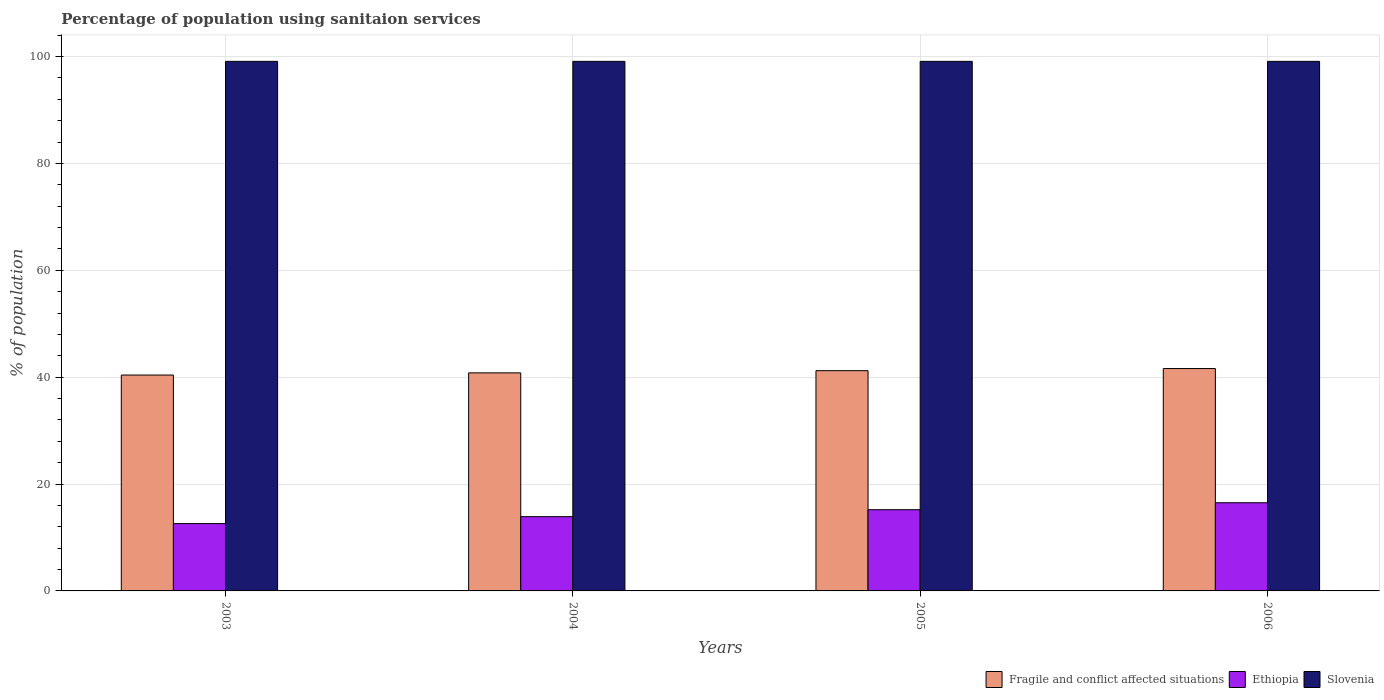Are the number of bars per tick equal to the number of legend labels?
Your answer should be very brief. Yes. How many bars are there on the 2nd tick from the left?
Provide a succinct answer. 3. In how many cases, is the number of bars for a given year not equal to the number of legend labels?
Your response must be concise. 0. What is the percentage of population using sanitaion services in Slovenia in 2005?
Give a very brief answer. 99.1. Across all years, what is the minimum percentage of population using sanitaion services in Ethiopia?
Provide a short and direct response. 12.6. In which year was the percentage of population using sanitaion services in Ethiopia minimum?
Your answer should be compact. 2003. What is the total percentage of population using sanitaion services in Ethiopia in the graph?
Provide a short and direct response. 58.2. What is the difference between the percentage of population using sanitaion services in Fragile and conflict affected situations in 2003 and that in 2004?
Keep it short and to the point. -0.41. What is the difference between the percentage of population using sanitaion services in Slovenia in 2006 and the percentage of population using sanitaion services in Ethiopia in 2004?
Provide a short and direct response. 85.2. What is the average percentage of population using sanitaion services in Ethiopia per year?
Your response must be concise. 14.55. In the year 2005, what is the difference between the percentage of population using sanitaion services in Ethiopia and percentage of population using sanitaion services in Fragile and conflict affected situations?
Your response must be concise. -26.02. In how many years, is the percentage of population using sanitaion services in Slovenia greater than 16 %?
Ensure brevity in your answer.  4. What is the ratio of the percentage of population using sanitaion services in Fragile and conflict affected situations in 2003 to that in 2004?
Keep it short and to the point. 0.99. Is the percentage of population using sanitaion services in Fragile and conflict affected situations in 2005 less than that in 2006?
Give a very brief answer. Yes. Is the difference between the percentage of population using sanitaion services in Ethiopia in 2005 and 2006 greater than the difference between the percentage of population using sanitaion services in Fragile and conflict affected situations in 2005 and 2006?
Provide a succinct answer. No. What is the difference between the highest and the second highest percentage of population using sanitaion services in Ethiopia?
Your answer should be very brief. 1.3. What is the difference between the highest and the lowest percentage of population using sanitaion services in Ethiopia?
Ensure brevity in your answer.  3.9. Is the sum of the percentage of population using sanitaion services in Ethiopia in 2003 and 2004 greater than the maximum percentage of population using sanitaion services in Fragile and conflict affected situations across all years?
Your response must be concise. No. What does the 3rd bar from the left in 2006 represents?
Provide a short and direct response. Slovenia. What does the 1st bar from the right in 2003 represents?
Make the answer very short. Slovenia. How many bars are there?
Ensure brevity in your answer.  12. Are all the bars in the graph horizontal?
Provide a short and direct response. No. How many years are there in the graph?
Ensure brevity in your answer.  4. What is the difference between two consecutive major ticks on the Y-axis?
Provide a succinct answer. 20. Are the values on the major ticks of Y-axis written in scientific E-notation?
Provide a succinct answer. No. How are the legend labels stacked?
Ensure brevity in your answer.  Horizontal. What is the title of the graph?
Ensure brevity in your answer.  Percentage of population using sanitaion services. What is the label or title of the Y-axis?
Your answer should be very brief. % of population. What is the % of population in Fragile and conflict affected situations in 2003?
Offer a very short reply. 40.4. What is the % of population in Slovenia in 2003?
Provide a succinct answer. 99.1. What is the % of population in Fragile and conflict affected situations in 2004?
Your response must be concise. 40.81. What is the % of population of Ethiopia in 2004?
Provide a succinct answer. 13.9. What is the % of population of Slovenia in 2004?
Ensure brevity in your answer.  99.1. What is the % of population of Fragile and conflict affected situations in 2005?
Provide a succinct answer. 41.22. What is the % of population of Ethiopia in 2005?
Offer a terse response. 15.2. What is the % of population in Slovenia in 2005?
Your answer should be compact. 99.1. What is the % of population of Fragile and conflict affected situations in 2006?
Your answer should be very brief. 41.61. What is the % of population of Slovenia in 2006?
Keep it short and to the point. 99.1. Across all years, what is the maximum % of population of Fragile and conflict affected situations?
Your response must be concise. 41.61. Across all years, what is the maximum % of population in Slovenia?
Ensure brevity in your answer.  99.1. Across all years, what is the minimum % of population of Fragile and conflict affected situations?
Your answer should be compact. 40.4. Across all years, what is the minimum % of population of Ethiopia?
Provide a succinct answer. 12.6. Across all years, what is the minimum % of population in Slovenia?
Provide a short and direct response. 99.1. What is the total % of population in Fragile and conflict affected situations in the graph?
Your response must be concise. 164.04. What is the total % of population of Ethiopia in the graph?
Make the answer very short. 58.2. What is the total % of population in Slovenia in the graph?
Your answer should be compact. 396.4. What is the difference between the % of population of Fragile and conflict affected situations in 2003 and that in 2004?
Offer a very short reply. -0.41. What is the difference between the % of population of Ethiopia in 2003 and that in 2004?
Offer a very short reply. -1.3. What is the difference between the % of population in Fragile and conflict affected situations in 2003 and that in 2005?
Make the answer very short. -0.82. What is the difference between the % of population in Ethiopia in 2003 and that in 2005?
Give a very brief answer. -2.6. What is the difference between the % of population in Fragile and conflict affected situations in 2003 and that in 2006?
Give a very brief answer. -1.22. What is the difference between the % of population in Fragile and conflict affected situations in 2004 and that in 2005?
Make the answer very short. -0.41. What is the difference between the % of population of Ethiopia in 2004 and that in 2005?
Your response must be concise. -1.3. What is the difference between the % of population of Fragile and conflict affected situations in 2004 and that in 2006?
Provide a succinct answer. -0.81. What is the difference between the % of population in Ethiopia in 2004 and that in 2006?
Provide a short and direct response. -2.6. What is the difference between the % of population in Slovenia in 2004 and that in 2006?
Provide a succinct answer. 0. What is the difference between the % of population of Fragile and conflict affected situations in 2005 and that in 2006?
Keep it short and to the point. -0.4. What is the difference between the % of population of Slovenia in 2005 and that in 2006?
Your response must be concise. 0. What is the difference between the % of population in Fragile and conflict affected situations in 2003 and the % of population in Ethiopia in 2004?
Keep it short and to the point. 26.5. What is the difference between the % of population in Fragile and conflict affected situations in 2003 and the % of population in Slovenia in 2004?
Your answer should be compact. -58.7. What is the difference between the % of population in Ethiopia in 2003 and the % of population in Slovenia in 2004?
Ensure brevity in your answer.  -86.5. What is the difference between the % of population of Fragile and conflict affected situations in 2003 and the % of population of Ethiopia in 2005?
Your answer should be very brief. 25.2. What is the difference between the % of population of Fragile and conflict affected situations in 2003 and the % of population of Slovenia in 2005?
Give a very brief answer. -58.7. What is the difference between the % of population of Ethiopia in 2003 and the % of population of Slovenia in 2005?
Your response must be concise. -86.5. What is the difference between the % of population of Fragile and conflict affected situations in 2003 and the % of population of Ethiopia in 2006?
Provide a succinct answer. 23.9. What is the difference between the % of population of Fragile and conflict affected situations in 2003 and the % of population of Slovenia in 2006?
Keep it short and to the point. -58.7. What is the difference between the % of population in Ethiopia in 2003 and the % of population in Slovenia in 2006?
Keep it short and to the point. -86.5. What is the difference between the % of population of Fragile and conflict affected situations in 2004 and the % of population of Ethiopia in 2005?
Offer a terse response. 25.61. What is the difference between the % of population in Fragile and conflict affected situations in 2004 and the % of population in Slovenia in 2005?
Offer a terse response. -58.29. What is the difference between the % of population of Ethiopia in 2004 and the % of population of Slovenia in 2005?
Provide a short and direct response. -85.2. What is the difference between the % of population in Fragile and conflict affected situations in 2004 and the % of population in Ethiopia in 2006?
Offer a terse response. 24.31. What is the difference between the % of population of Fragile and conflict affected situations in 2004 and the % of population of Slovenia in 2006?
Your answer should be compact. -58.29. What is the difference between the % of population of Ethiopia in 2004 and the % of population of Slovenia in 2006?
Your answer should be compact. -85.2. What is the difference between the % of population of Fragile and conflict affected situations in 2005 and the % of population of Ethiopia in 2006?
Provide a short and direct response. 24.72. What is the difference between the % of population in Fragile and conflict affected situations in 2005 and the % of population in Slovenia in 2006?
Keep it short and to the point. -57.88. What is the difference between the % of population in Ethiopia in 2005 and the % of population in Slovenia in 2006?
Offer a very short reply. -83.9. What is the average % of population of Fragile and conflict affected situations per year?
Offer a terse response. 41.01. What is the average % of population in Ethiopia per year?
Provide a succinct answer. 14.55. What is the average % of population in Slovenia per year?
Give a very brief answer. 99.1. In the year 2003, what is the difference between the % of population of Fragile and conflict affected situations and % of population of Ethiopia?
Offer a very short reply. 27.8. In the year 2003, what is the difference between the % of population of Fragile and conflict affected situations and % of population of Slovenia?
Your answer should be very brief. -58.7. In the year 2003, what is the difference between the % of population in Ethiopia and % of population in Slovenia?
Your response must be concise. -86.5. In the year 2004, what is the difference between the % of population in Fragile and conflict affected situations and % of population in Ethiopia?
Offer a terse response. 26.91. In the year 2004, what is the difference between the % of population of Fragile and conflict affected situations and % of population of Slovenia?
Your answer should be very brief. -58.29. In the year 2004, what is the difference between the % of population in Ethiopia and % of population in Slovenia?
Your answer should be compact. -85.2. In the year 2005, what is the difference between the % of population in Fragile and conflict affected situations and % of population in Ethiopia?
Give a very brief answer. 26.02. In the year 2005, what is the difference between the % of population in Fragile and conflict affected situations and % of population in Slovenia?
Offer a very short reply. -57.88. In the year 2005, what is the difference between the % of population of Ethiopia and % of population of Slovenia?
Offer a terse response. -83.9. In the year 2006, what is the difference between the % of population of Fragile and conflict affected situations and % of population of Ethiopia?
Ensure brevity in your answer.  25.11. In the year 2006, what is the difference between the % of population of Fragile and conflict affected situations and % of population of Slovenia?
Your answer should be very brief. -57.49. In the year 2006, what is the difference between the % of population of Ethiopia and % of population of Slovenia?
Your answer should be compact. -82.6. What is the ratio of the % of population of Fragile and conflict affected situations in 2003 to that in 2004?
Offer a very short reply. 0.99. What is the ratio of the % of population in Ethiopia in 2003 to that in 2004?
Make the answer very short. 0.91. What is the ratio of the % of population in Slovenia in 2003 to that in 2004?
Your response must be concise. 1. What is the ratio of the % of population of Fragile and conflict affected situations in 2003 to that in 2005?
Give a very brief answer. 0.98. What is the ratio of the % of population in Ethiopia in 2003 to that in 2005?
Provide a succinct answer. 0.83. What is the ratio of the % of population of Slovenia in 2003 to that in 2005?
Provide a short and direct response. 1. What is the ratio of the % of population in Fragile and conflict affected situations in 2003 to that in 2006?
Ensure brevity in your answer.  0.97. What is the ratio of the % of population of Ethiopia in 2003 to that in 2006?
Provide a succinct answer. 0.76. What is the ratio of the % of population in Ethiopia in 2004 to that in 2005?
Provide a short and direct response. 0.91. What is the ratio of the % of population of Slovenia in 2004 to that in 2005?
Make the answer very short. 1. What is the ratio of the % of population of Fragile and conflict affected situations in 2004 to that in 2006?
Offer a very short reply. 0.98. What is the ratio of the % of population of Ethiopia in 2004 to that in 2006?
Offer a very short reply. 0.84. What is the ratio of the % of population of Slovenia in 2004 to that in 2006?
Ensure brevity in your answer.  1. What is the ratio of the % of population in Fragile and conflict affected situations in 2005 to that in 2006?
Offer a very short reply. 0.99. What is the ratio of the % of population of Ethiopia in 2005 to that in 2006?
Your answer should be very brief. 0.92. What is the ratio of the % of population of Slovenia in 2005 to that in 2006?
Your answer should be very brief. 1. What is the difference between the highest and the second highest % of population of Fragile and conflict affected situations?
Your answer should be compact. 0.4. What is the difference between the highest and the second highest % of population of Ethiopia?
Give a very brief answer. 1.3. What is the difference between the highest and the second highest % of population in Slovenia?
Give a very brief answer. 0. What is the difference between the highest and the lowest % of population of Fragile and conflict affected situations?
Provide a succinct answer. 1.22. What is the difference between the highest and the lowest % of population of Slovenia?
Provide a succinct answer. 0. 